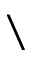<formula> <loc_0><loc_0><loc_500><loc_500>\</formula> 